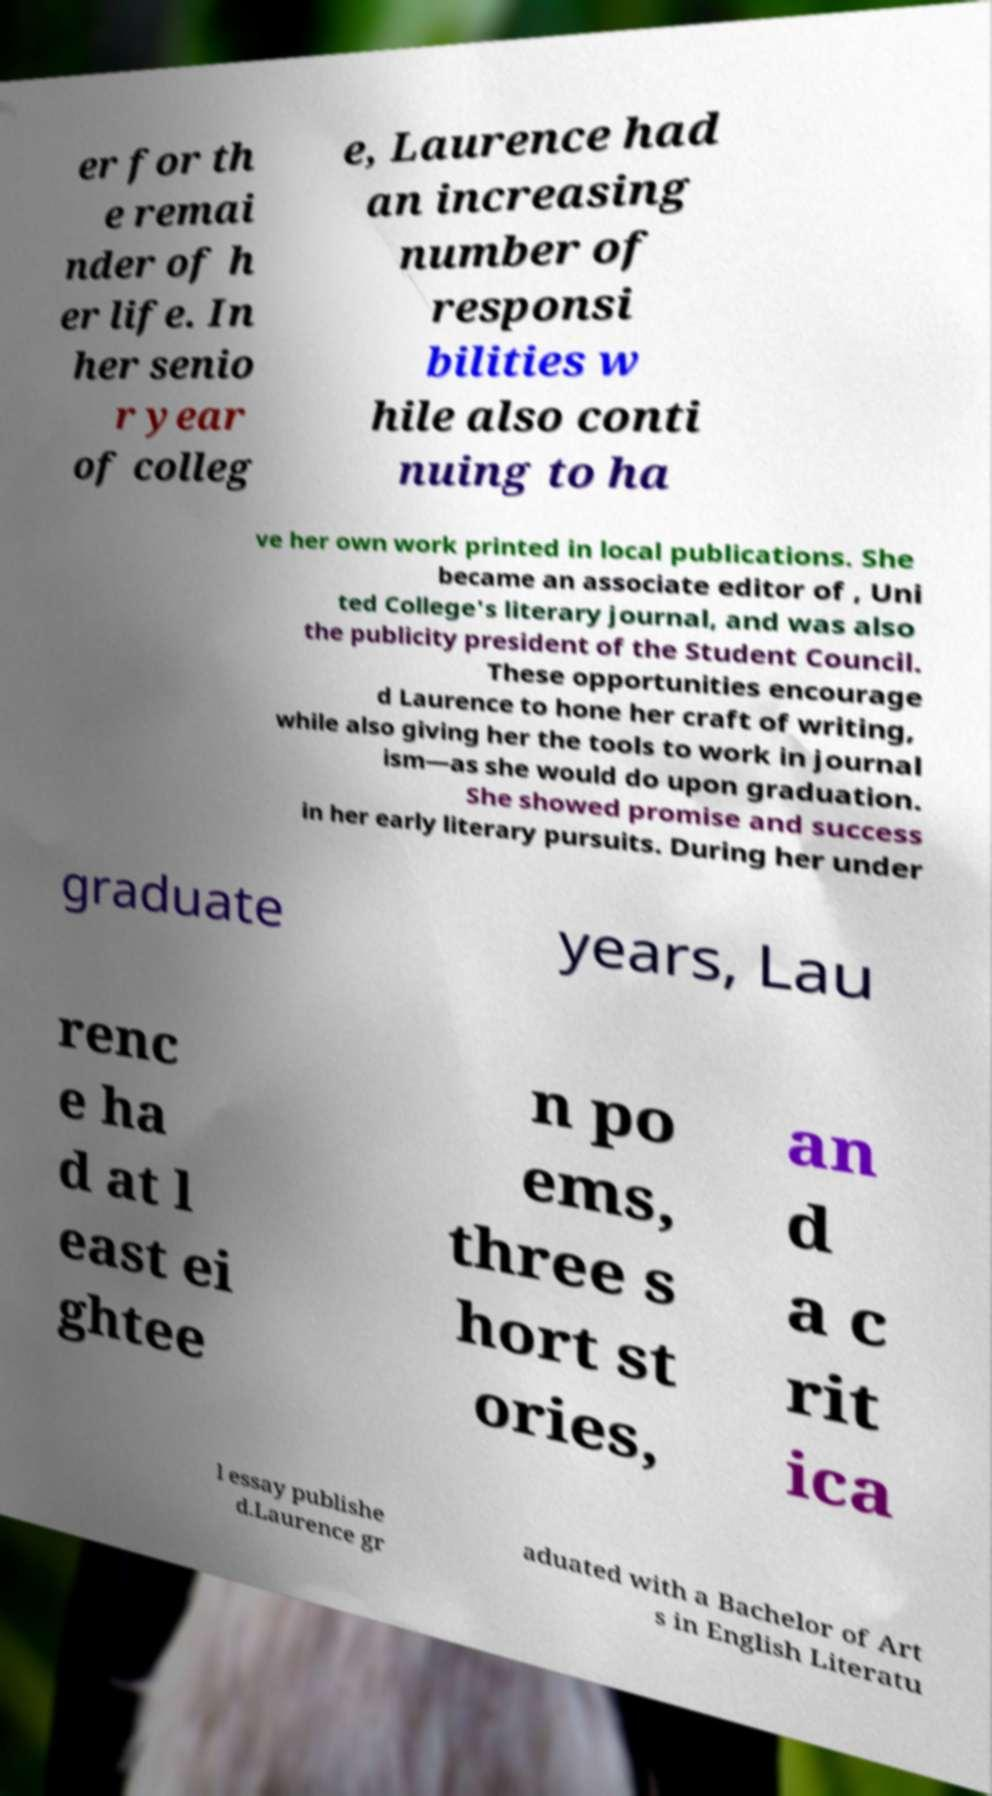For documentation purposes, I need the text within this image transcribed. Could you provide that? er for th e remai nder of h er life. In her senio r year of colleg e, Laurence had an increasing number of responsi bilities w hile also conti nuing to ha ve her own work printed in local publications. She became an associate editor of , Uni ted College's literary journal, and was also the publicity president of the Student Council. These opportunities encourage d Laurence to hone her craft of writing, while also giving her the tools to work in journal ism—as she would do upon graduation. She showed promise and success in her early literary pursuits. During her under graduate years, Lau renc e ha d at l east ei ghtee n po ems, three s hort st ories, an d a c rit ica l essay publishe d.Laurence gr aduated with a Bachelor of Art s in English Literatu 